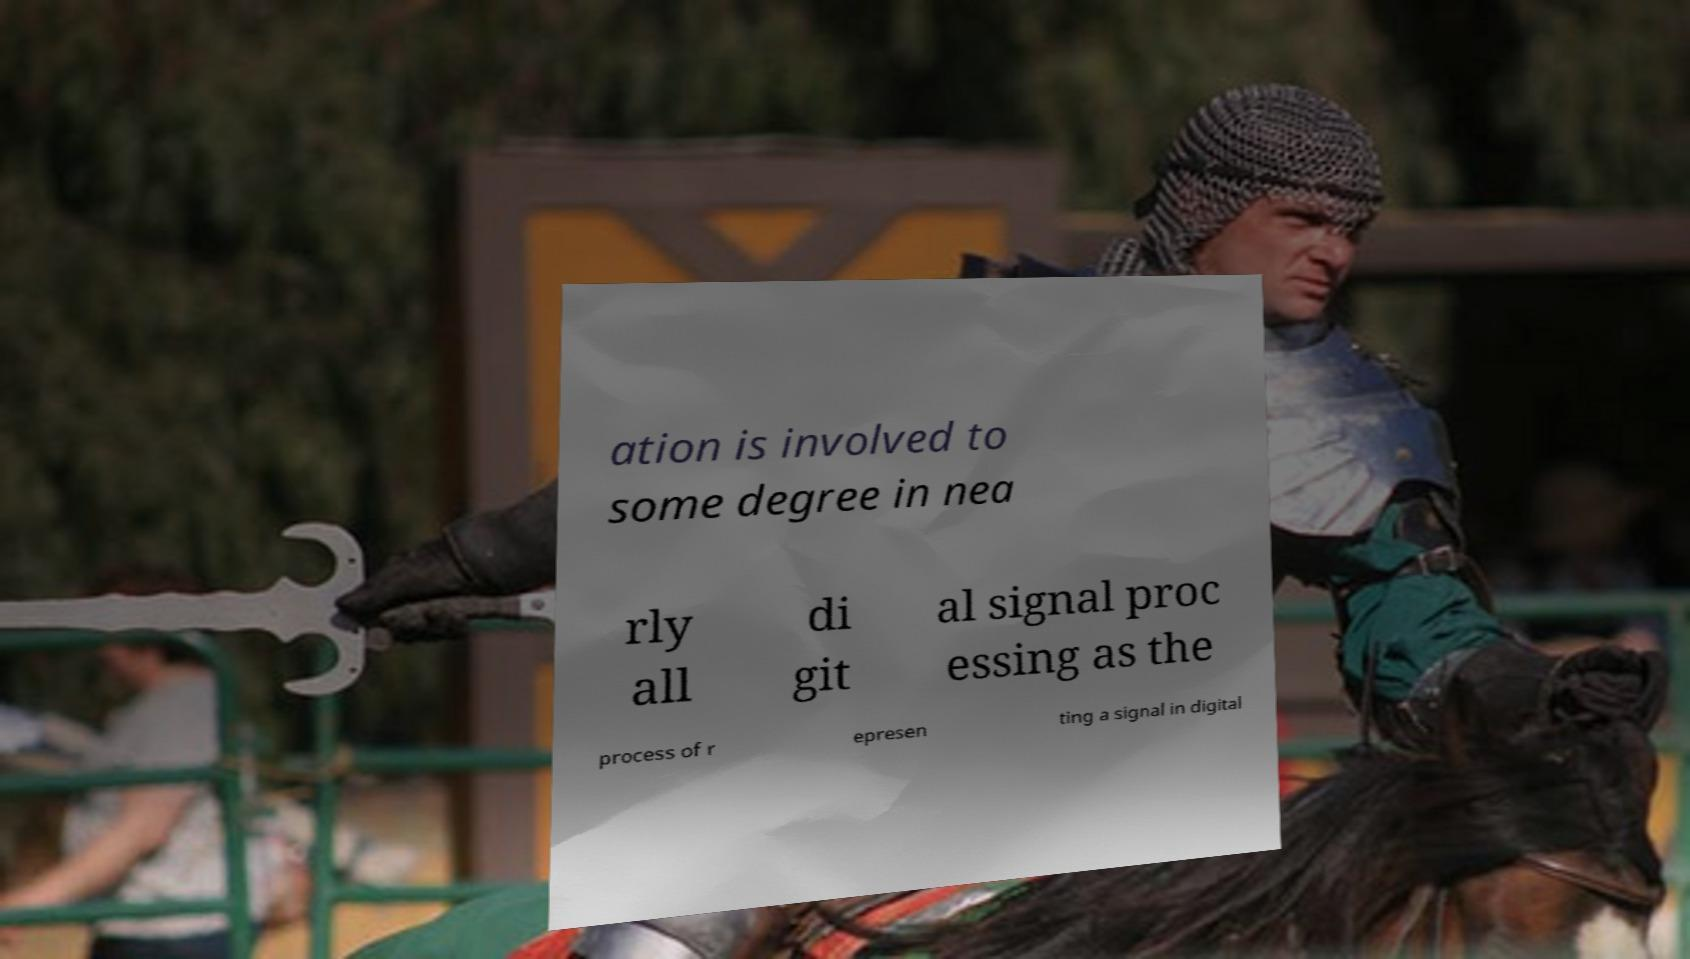Could you assist in decoding the text presented in this image and type it out clearly? ation is involved to some degree in nea rly all di git al signal proc essing as the process of r epresen ting a signal in digital 